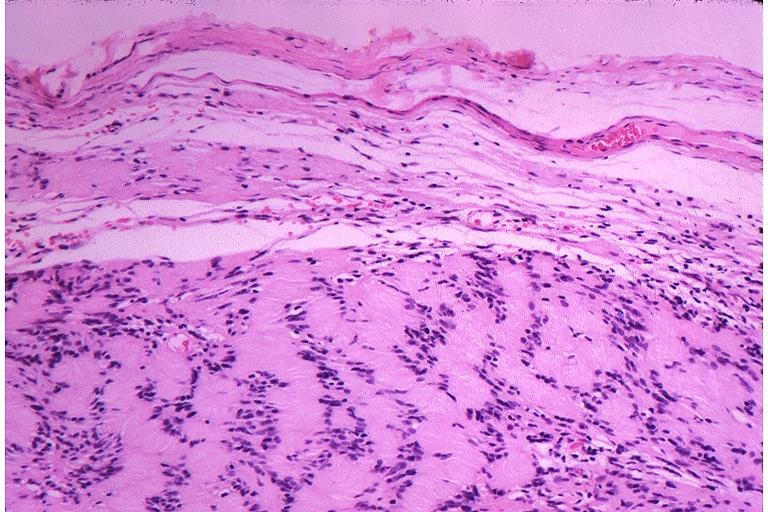does hemorrhagic corpus luteum show schwanoma neurilemoma?
Answer the question using a single word or phrase. No 